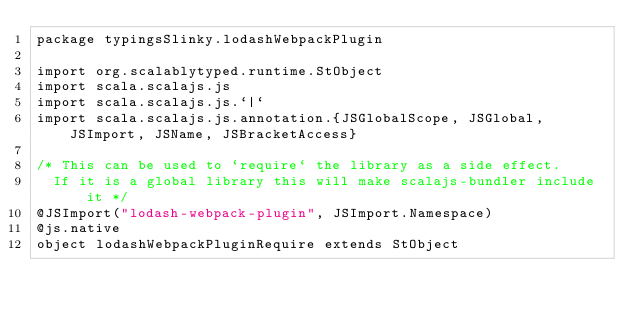Convert code to text. <code><loc_0><loc_0><loc_500><loc_500><_Scala_>package typingsSlinky.lodashWebpackPlugin

import org.scalablytyped.runtime.StObject
import scala.scalajs.js
import scala.scalajs.js.`|`
import scala.scalajs.js.annotation.{JSGlobalScope, JSGlobal, JSImport, JSName, JSBracketAccess}

/* This can be used to `require` the library as a side effect.
  If it is a global library this will make scalajs-bundler include it */
@JSImport("lodash-webpack-plugin", JSImport.Namespace)
@js.native
object lodashWebpackPluginRequire extends StObject
</code> 